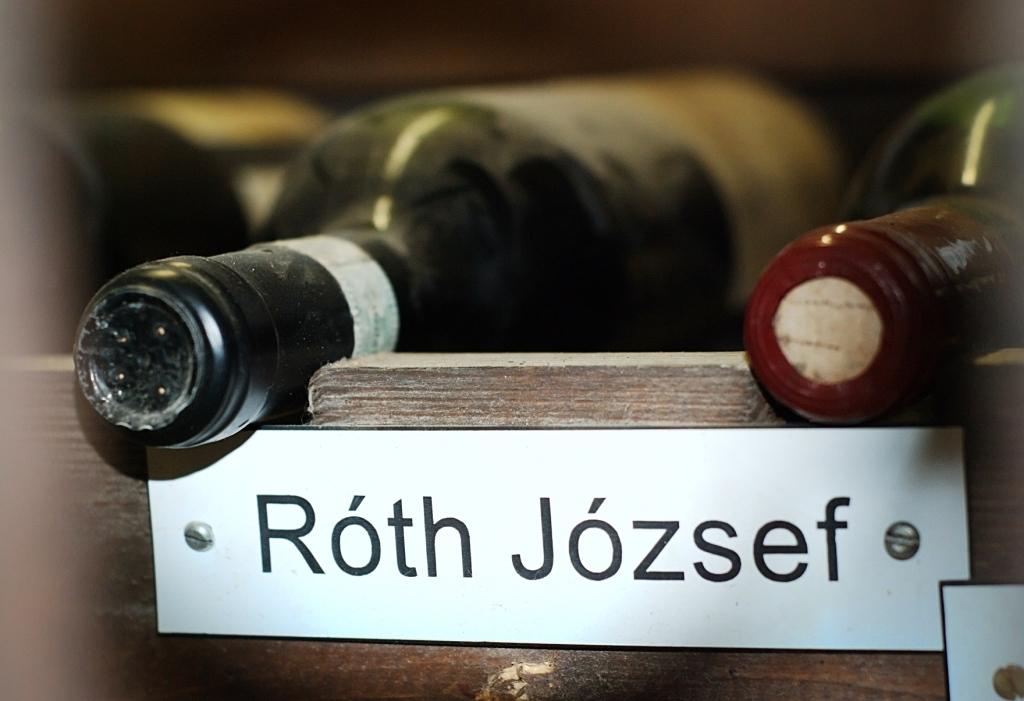What brand is this wine?
Your answer should be compact. Roth jozsef. 